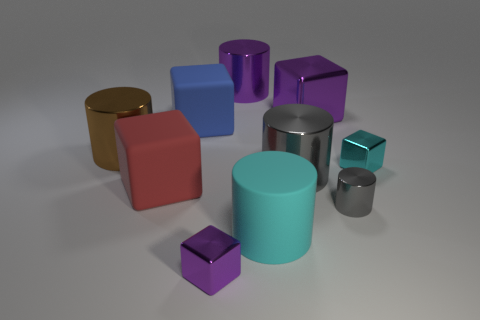What is the color of the rubber cylinder?
Your answer should be compact. Cyan. There is a small block that is in front of the tiny cyan object; is its color the same as the big metallic cube?
Your answer should be very brief. Yes. What number of tiny metallic cubes are the same color as the large matte cylinder?
Your answer should be very brief. 1. What is the size of the other metallic block that is the same color as the large shiny block?
Your answer should be very brief. Small. There is a brown metal cylinder that is to the left of the cyan block; is its size the same as the block that is right of the large purple block?
Your response must be concise. No. There is a cyan thing that is in front of the big rubber cube that is to the left of the blue rubber object; what is it made of?
Provide a succinct answer. Rubber. Are there any other things that are the same color as the small cylinder?
Provide a short and direct response. Yes. There is a metal cylinder right of the gray cylinder that is behind the tiny gray metallic object that is in front of the big brown object; what is its color?
Provide a succinct answer. Gray. There is a gray object that is left of the big block that is right of the tiny purple cube; how big is it?
Ensure brevity in your answer.  Large. There is a large cylinder that is behind the tiny cyan metal object and right of the red object; what material is it?
Keep it short and to the point. Metal. 